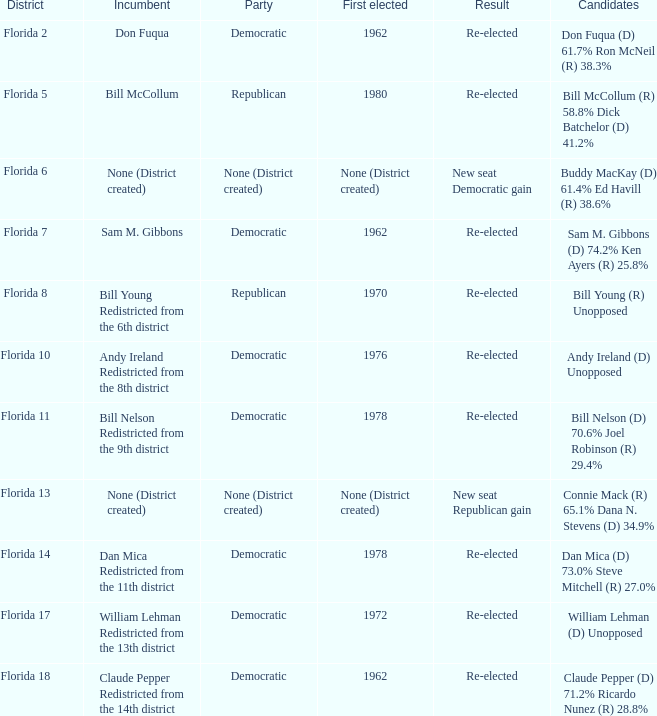How many candidates contributed to the democratic party's gain of new seats? 1.0. 